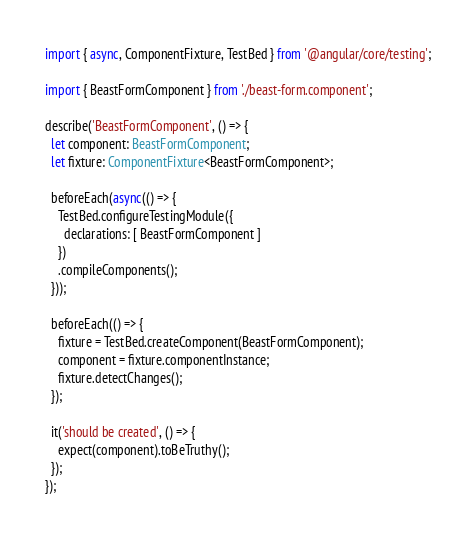<code> <loc_0><loc_0><loc_500><loc_500><_TypeScript_>import { async, ComponentFixture, TestBed } from '@angular/core/testing';

import { BeastFormComponent } from './beast-form.component';

describe('BeastFormComponent', () => {
  let component: BeastFormComponent;
  let fixture: ComponentFixture<BeastFormComponent>;

  beforeEach(async(() => {
    TestBed.configureTestingModule({
      declarations: [ BeastFormComponent ]
    })
    .compileComponents();
  }));

  beforeEach(() => {
    fixture = TestBed.createComponent(BeastFormComponent);
    component = fixture.componentInstance;
    fixture.detectChanges();
  });

  it('should be created', () => {
    expect(component).toBeTruthy();
  });
});
</code> 